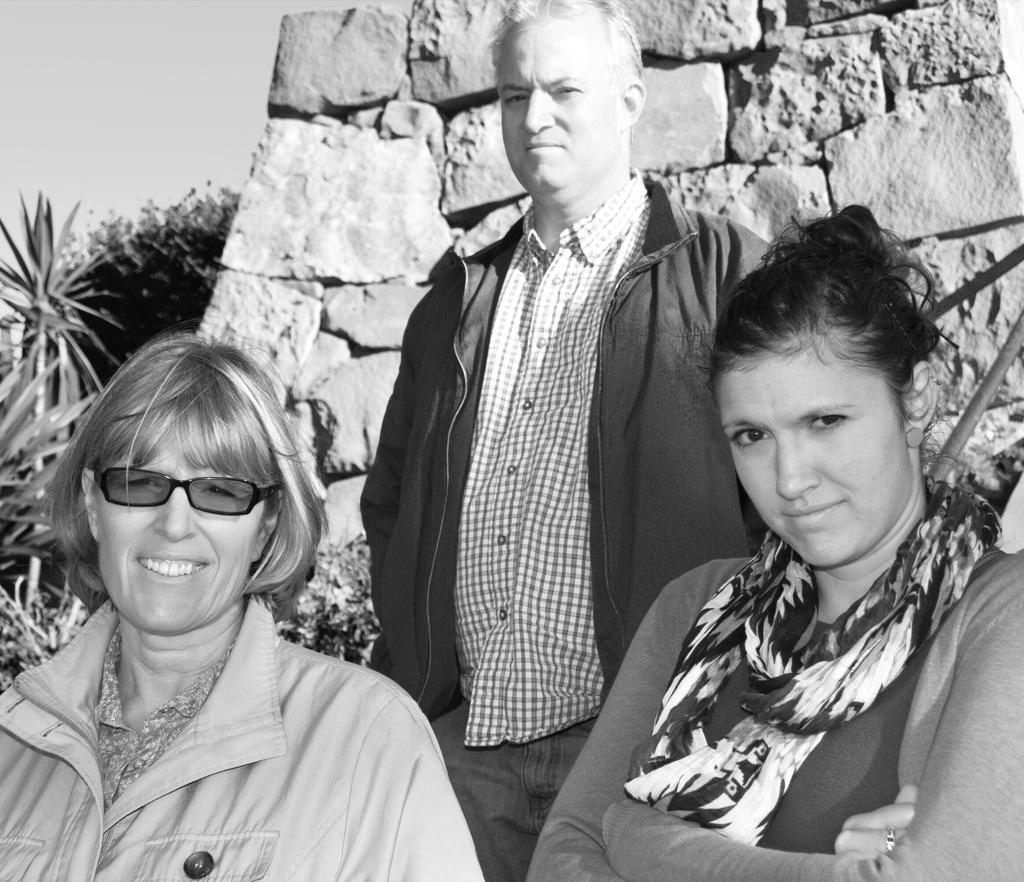How many women are in the image? There are two women in the image. Can you describe the person standing behind the two women? There is a person standing behind the two women, but their appearance is not specified in the facts. What can be seen in the background of the image? There is a rock wall and trees in the background of the image. What type of cracker is the person holding in the image? There is no mention of a cracker or any food item in the image. How many fingers does the person have on their left hand in the image? The facts do not provide information about the person's fingers or hands. 